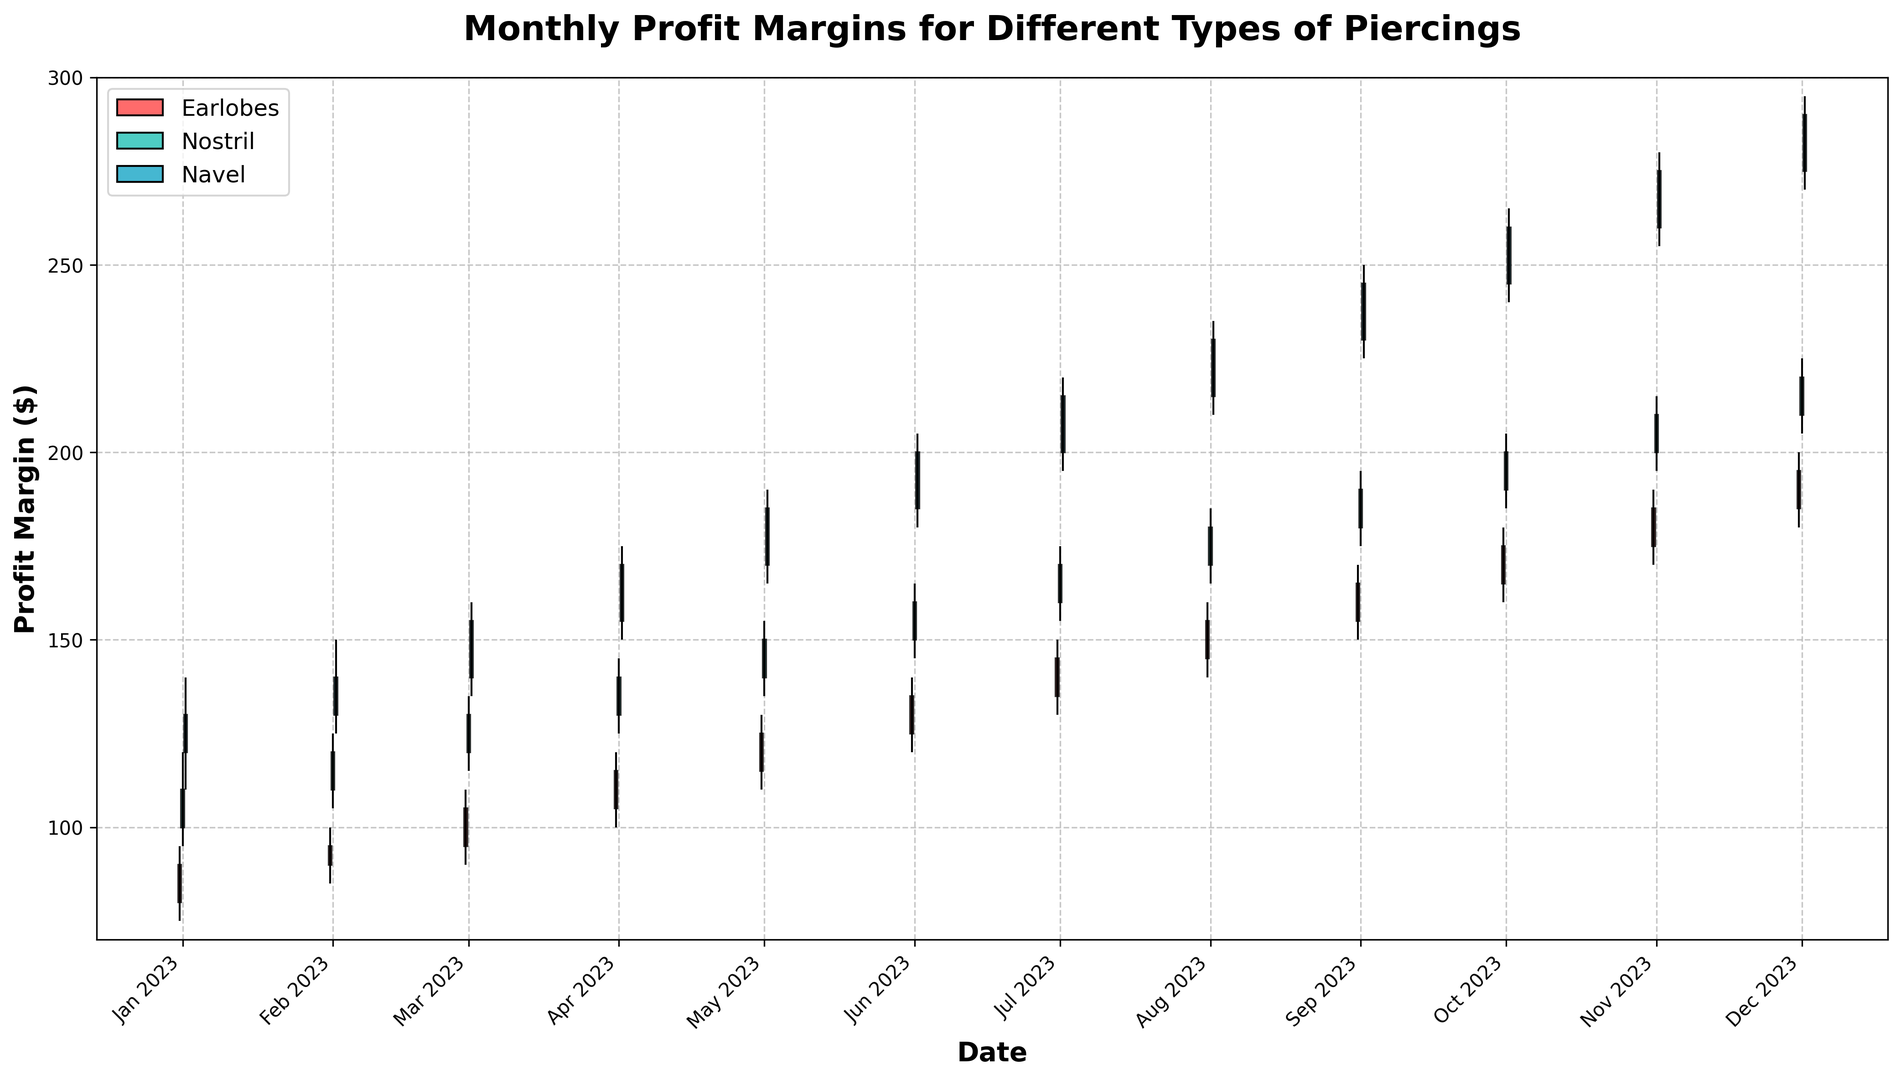What is the overall trend for Navel piercings profit margins from January to December? The trend for Navel piercings starts with an upward trajectory from January ($130) through December ($290), with a notable steady increase every month without any dips.
Answer: Upward trend How does the profit margin for Earlobes in December compare to January? In January, the Earlobes profit margin closes at $90, whereas in December, it closes at $195. December's profit margin is higher by $105 compared to January.
Answer: Higher by $105 Which piercing type shows the greatest increase in profit margins from June to July? For Earlobes, the increase from June ($135) to July ($145) is $10. For Nostril, the increase from June ($160) to July ($170) is $10. For Navel, the increase from June ($200) to July ($215) is $15. The Navel piercing shows the greatest increase of $15.
Answer: Navel Between which months does the Nostril piercing experience the smallest change in profit margin? The smallest change in Nostril profit margins is between October ($200) and November ($210), where the change is only $10.
Answer: October and November What is the highest profit margin recorded for any piercing type during the year, and which month and type does it occur? The highest profit margin recorded is for Navel piercings in December, closing at $290.
Answer: Navel in December, $290 How does the profit margin for Earlobes in February compare to its high and low values for that month? In February, the Earlobes profit margin closes at $95, with a high of $100 and a low of $85. The closing margin is $5 below the high and $10 above the low.
Answer: $5 below high, $10 above low Which month shows the highest profit margin for Nostril piercings? The highest closing profit margin for Nostril piercings is recorded in December at $220.
Answer: December Was there any month where the Earlobes' profit margin decreased? If so, which one? The Earlobes profit margin decreases from January ($90) to February ($95), showing a consistent month-over-month increase with no months of decline.
Answer: No month of decrease What is the difference between the highest and lowest monthly closing profits for Navel piercings? The highest closing profit for Navel piercings is in December ($290) and the lowest is in January ($130). The difference is $160.
Answer: $160 Which piercing type demonstrates the least volatility (fluctuation between high and low) in profit margins over the year? By examining the range between the high and low values for each month and comparing across piercing types, the Earlobes generally show smaller ranges, indicating less volatility.
Answer: Earlobes 